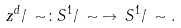Convert formula to latex. <formula><loc_0><loc_0><loc_500><loc_500>z ^ { d } / \, \sim \colon S ^ { 1 } / \, \sim \, \to \, S ^ { 1 } / \, \sim .</formula> 